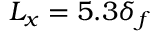<formula> <loc_0><loc_0><loc_500><loc_500>L _ { x } = 5 . 3 \delta _ { f }</formula> 